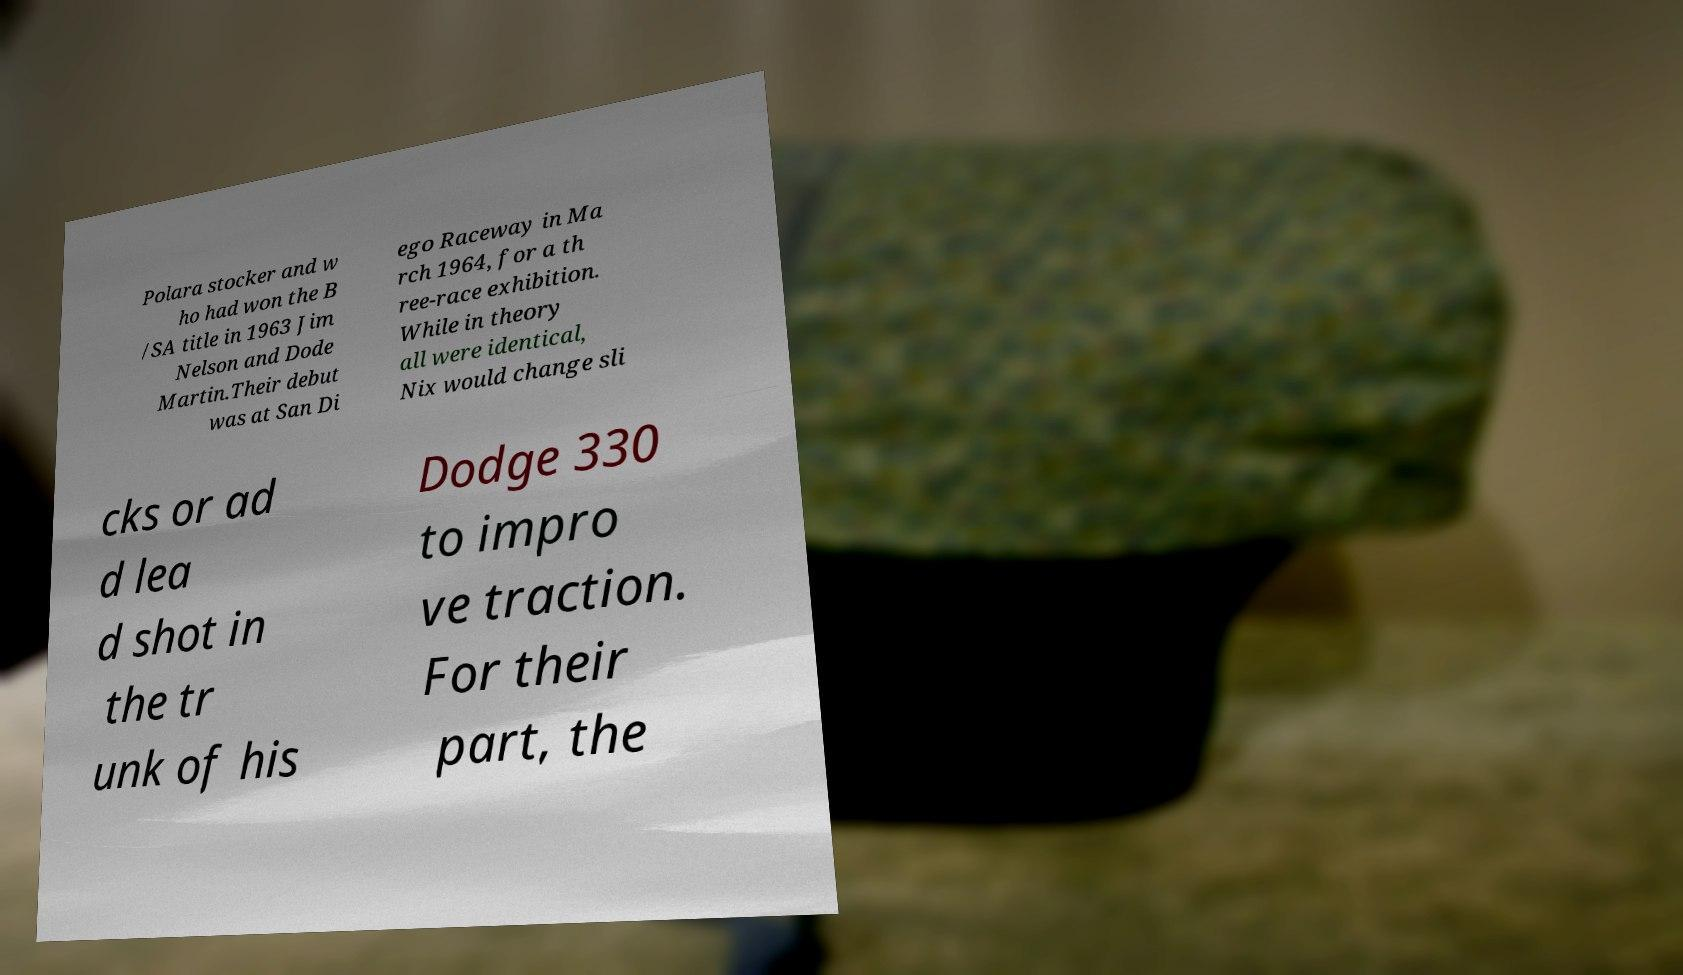What messages or text are displayed in this image? I need them in a readable, typed format. Polara stocker and w ho had won the B /SA title in 1963 Jim Nelson and Dode Martin.Their debut was at San Di ego Raceway in Ma rch 1964, for a th ree-race exhibition. While in theory all were identical, Nix would change sli cks or ad d lea d shot in the tr unk of his Dodge 330 to impro ve traction. For their part, the 